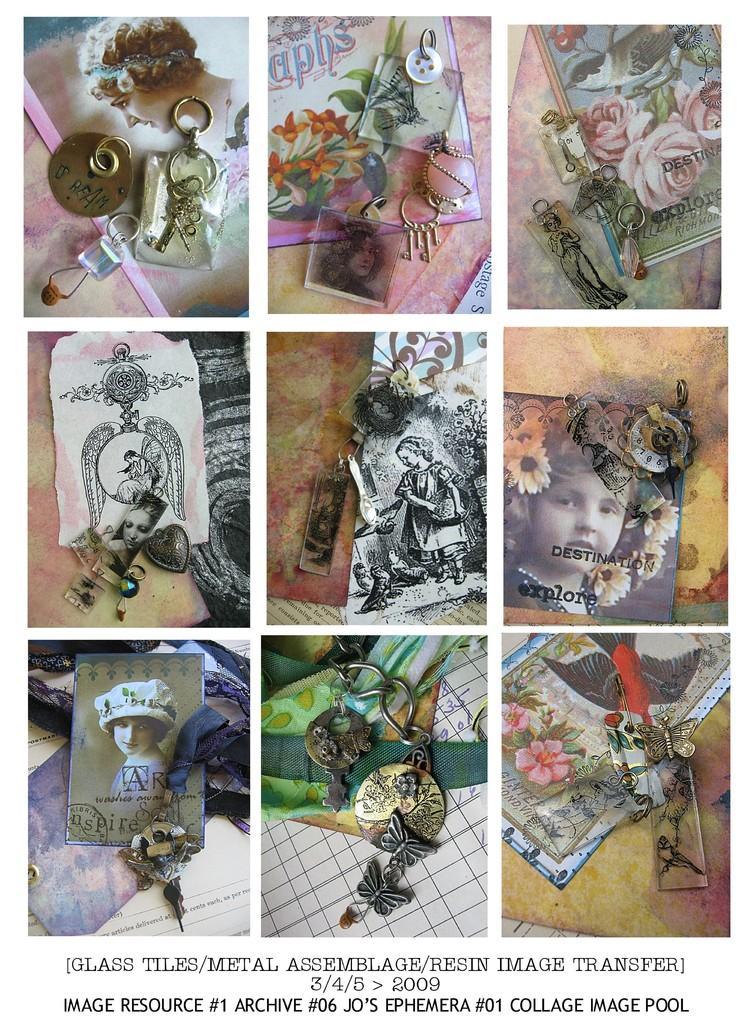Can you describe this image briefly? This is the college of some images. We can see some pictures and objects in each of the images. We can also see some text at the bottom. 